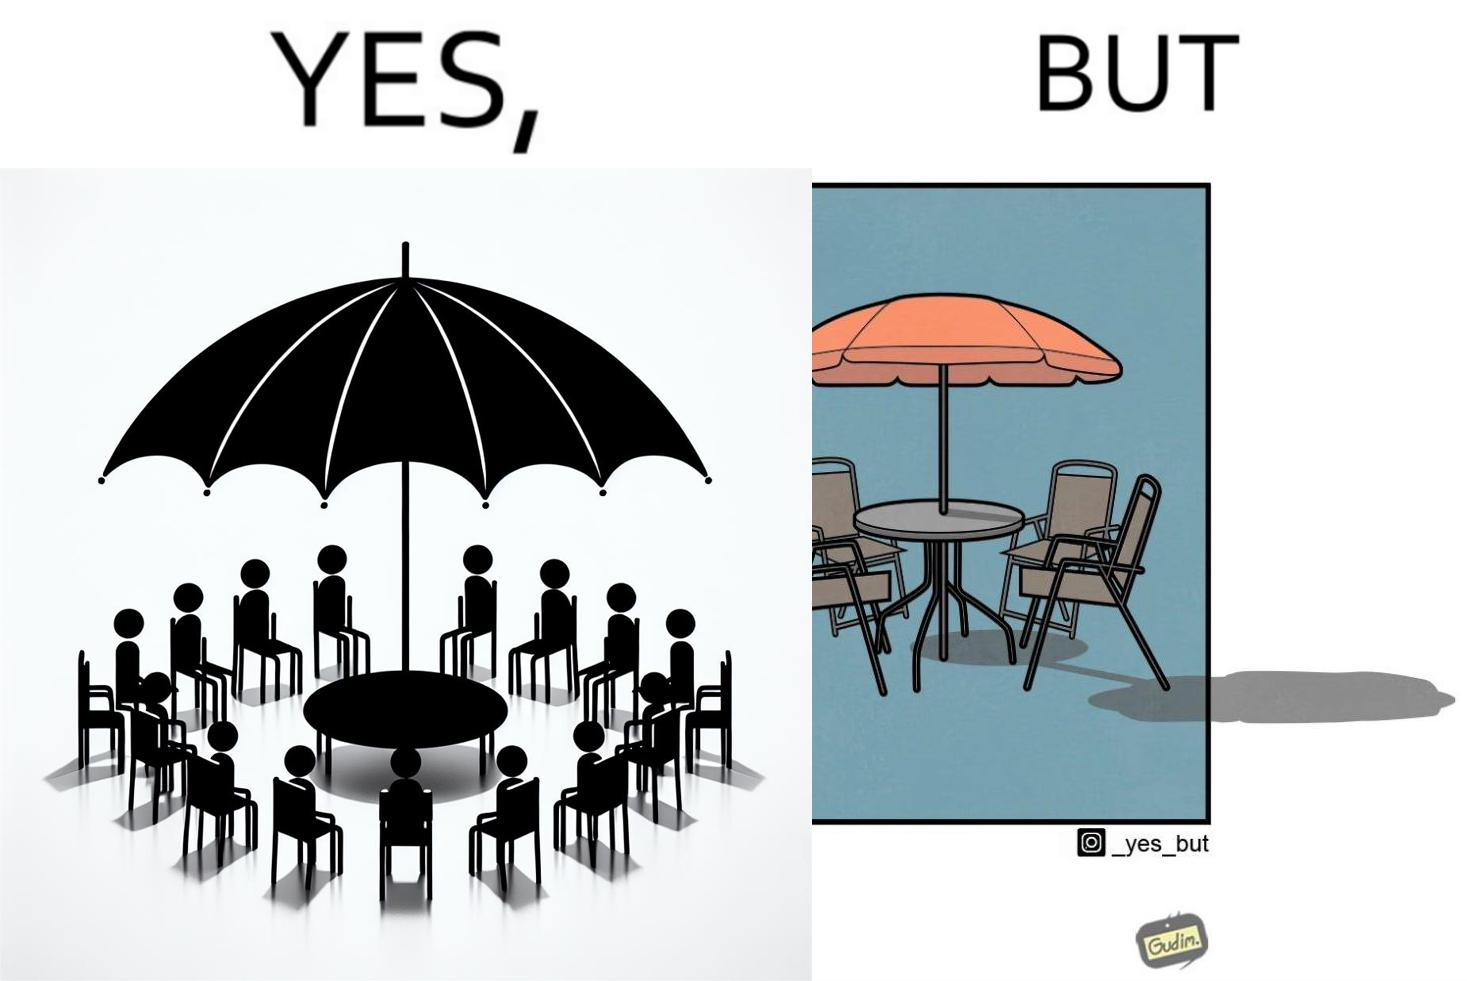Compare the left and right sides of this image. In the left part of the image: Chairs surrounding a table under a large umbrella. In the right part of the image: Chairs surrounding a table under a large umbrella, with the shadow of the umbrella appearing on the side. 